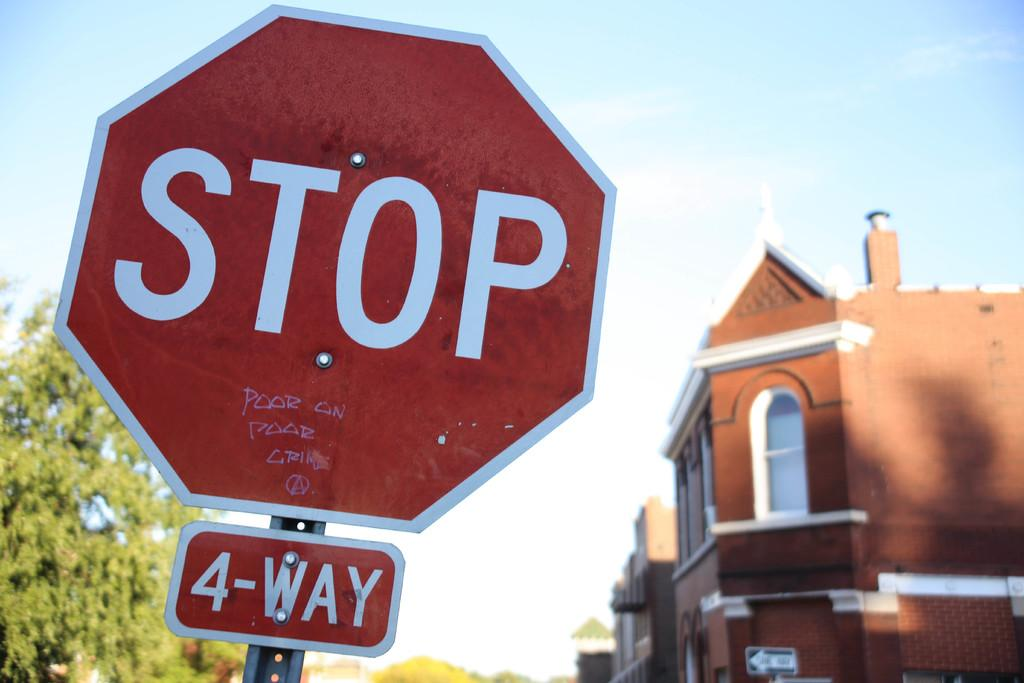<image>
Provide a brief description of the given image. A stop sign with another small informational sign below it saying 4-Way. 